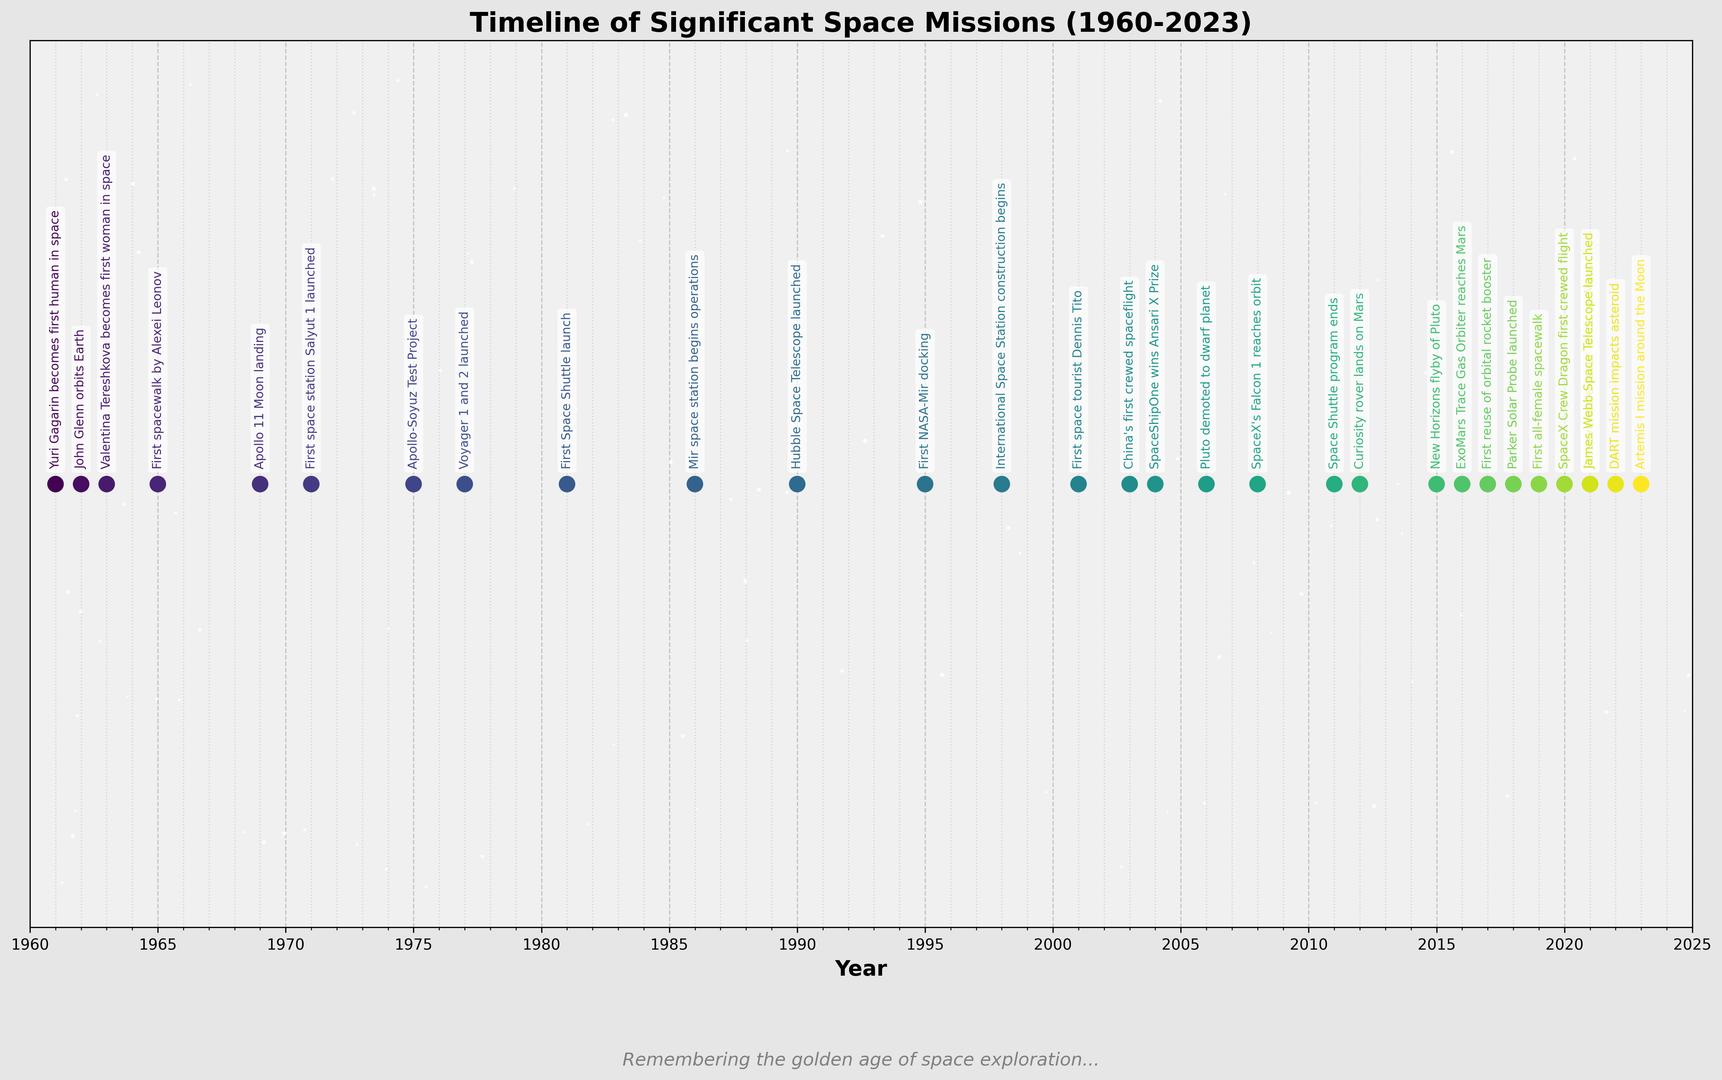Which event occurred first, Yuri Gagarin's spaceflight or the Apollo 11 Moon landing? Gagarin's spaceflight happened in 1961, while the Apollo 11 Moon landing took place in 1969. Comparing the years, Gagarin's spaceflight came first.
Answer: Yuri Gagarin's spaceflight How many years passed between the first space station launch and the beginning of International Space Station construction? The first space station, Salyut 1, launched in 1971. The International Space Station's construction began in 1998. Subtract 1971 from 1998 to get 27 years.
Answer: 27 years Which came first, China's first crewed spaceflight or SpaceShipOne's Ansari X Prize win? China's first crewed spaceflight was in 2003, and SpaceShipOne's win was in 2004. Comparing the years, China's mission came first.
Answer: China's first crewed spaceflight What is the median year of the events listed? There are 27 events. The median year corresponds to the 14th event when the years are sorted. The 14th event year is 2001 related to the first space tourist.
Answer: 2001 Which event happened closest to the year 1985? Events near 1985 include the first Space Shuttle launch in 1981 and Mir space station operations in 1986. Since 1986 is closer to 1985, the answer is the Mir space station.
Answer: Mir space station operations How many events occurred before the year 1990? Events before 1990 include ones from 1961, 1962, 1963, 1965, 1969, 1971, 1975, 1977, 1981, and 1986, totaling 10 events.
Answer: 10 events How many years passed between the end of the Space Shuttle program and the first all-female spacewalk? The Space Shuttle program ended in 2011, and the first all-female spacewalk occurred in 2019. Subtracting 2011 from 2019, we get 8 years.
Answer: 8 years Which milestone happened first: the launch of Hubble Space Telescope or the first NASA-Mir docking? Hubble Space Telescope was launched in 1990 while the first NASA-Mir docking happened in 1995. Comparing the years, Hubble's launch happened first.
Answer: Hubble Space Telescope launch 